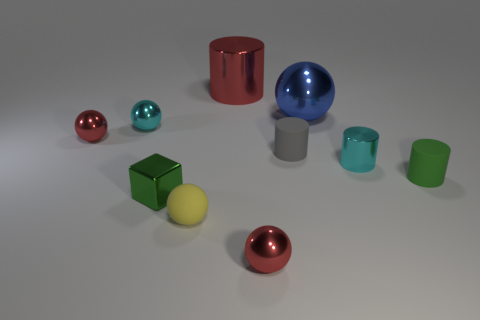How many objects are either small green metallic objects or spheres on the left side of the yellow ball?
Provide a short and direct response. 3. There is a shiny object behind the big sphere; is its size the same as the cyan metallic thing in front of the cyan shiny sphere?
Keep it short and to the point. No. Is there a small cylinder made of the same material as the green block?
Your answer should be compact. Yes. What is the shape of the yellow thing?
Provide a succinct answer. Sphere. The red metallic thing behind the tiny red shiny sphere behind the green metallic thing is what shape?
Ensure brevity in your answer.  Cylinder. What number of other things are there of the same shape as the tiny yellow matte object?
Your response must be concise. 4. What size is the blue sphere on the left side of the green thing on the right side of the red metallic cylinder?
Give a very brief answer. Large. Are any green rubber cylinders visible?
Your answer should be very brief. Yes. There is a green thing on the right side of the big red shiny cylinder; how many tiny green cylinders are on the left side of it?
Offer a very short reply. 0. The green object on the right side of the red metallic cylinder has what shape?
Your response must be concise. Cylinder. 